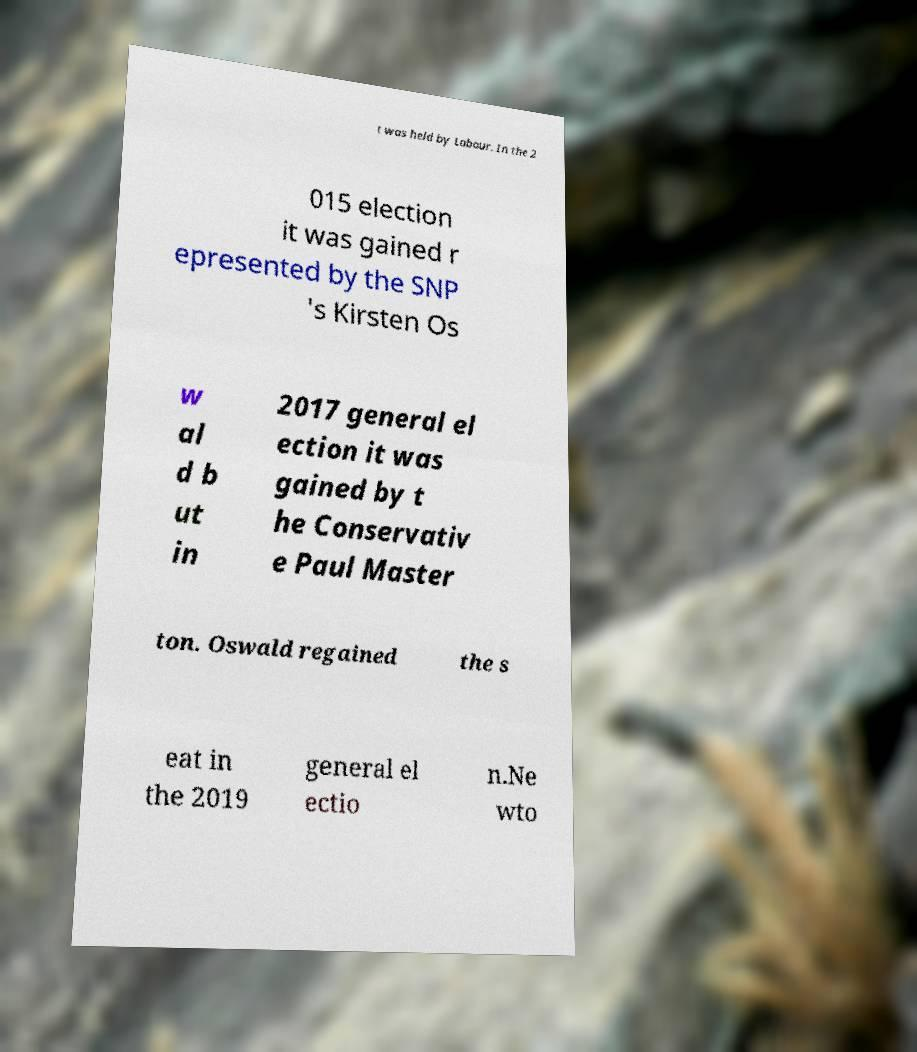Could you assist in decoding the text presented in this image and type it out clearly? t was held by Labour. In the 2 015 election it was gained r epresented by the SNP 's Kirsten Os w al d b ut in 2017 general el ection it was gained by t he Conservativ e Paul Master ton. Oswald regained the s eat in the 2019 general el ectio n.Ne wto 